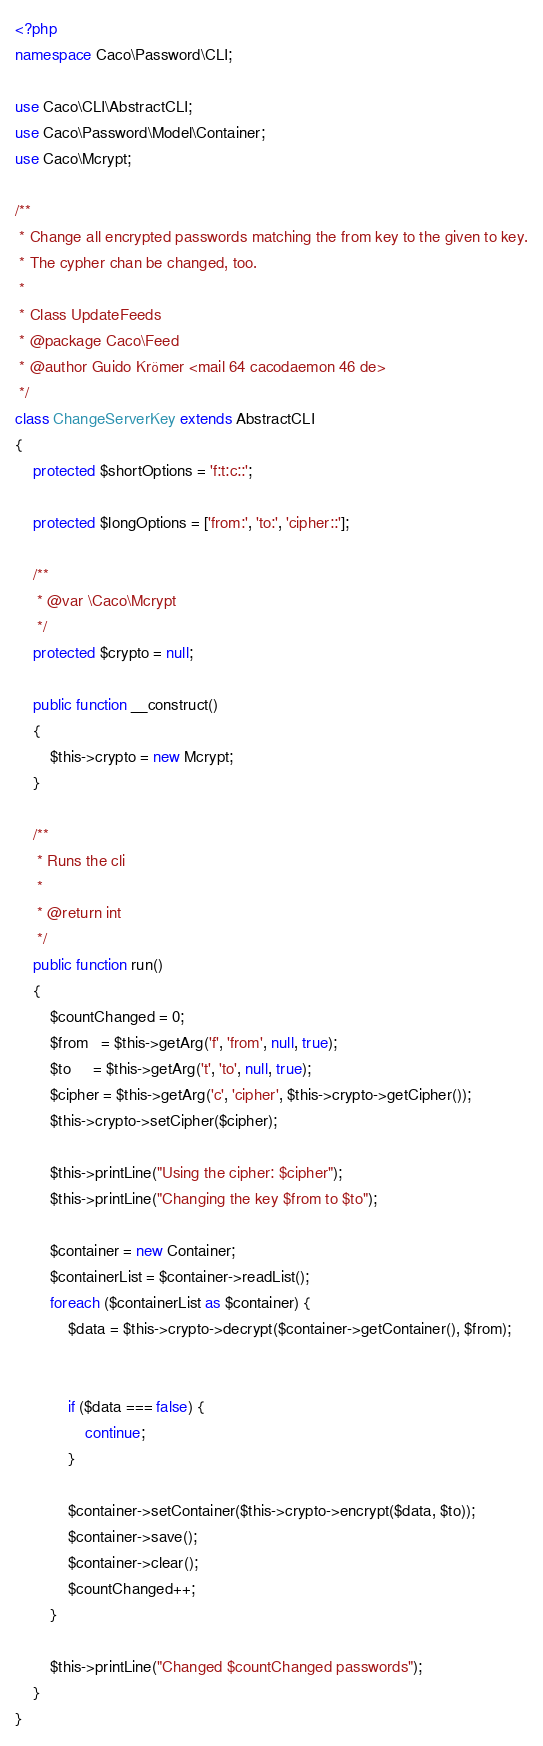Convert code to text. <code><loc_0><loc_0><loc_500><loc_500><_PHP_><?php
namespace Caco\Password\CLI;

use Caco\CLI\AbstractCLI;
use Caco\Password\Model\Container;
use Caco\Mcrypt;

/**
 * Change all encrypted passwords matching the from key to the given to key.
 * The cypher chan be changed, too.
 *
 * Class UpdateFeeds
 * @package Caco\Feed
 * @author Guido Krömer <mail 64 cacodaemon 46 de>
 */
class ChangeServerKey extends AbstractCLI
{
    protected $shortOptions = 'f:t:c::';

    protected $longOptions = ['from:', 'to:', 'cipher::'];

    /**
     * @var \Caco\Mcrypt
     */
    protected $crypto = null;

    public function __construct()
    {
        $this->crypto = new Mcrypt;
    }

    /**
     * Runs the cli
     *
     * @return int
     */
    public function run()
    {
        $countChanged = 0;
        $from   = $this->getArg('f', 'from', null, true);
        $to     = $this->getArg('t', 'to', null, true);
        $cipher = $this->getArg('c', 'cipher', $this->crypto->getCipher());
        $this->crypto->setCipher($cipher);

        $this->printLine("Using the cipher: $cipher");
        $this->printLine("Changing the key $from to $to");

        $container = new Container;
        $containerList = $container->readList();
        foreach ($containerList as $container) {
            $data = $this->crypto->decrypt($container->getContainer(), $from);


            if ($data === false) {
                continue;
            }

            $container->setContainer($this->crypto->encrypt($data, $to));
            $container->save();
            $container->clear();
            $countChanged++;
        }

        $this->printLine("Changed $countChanged passwords");
    }
}</code> 